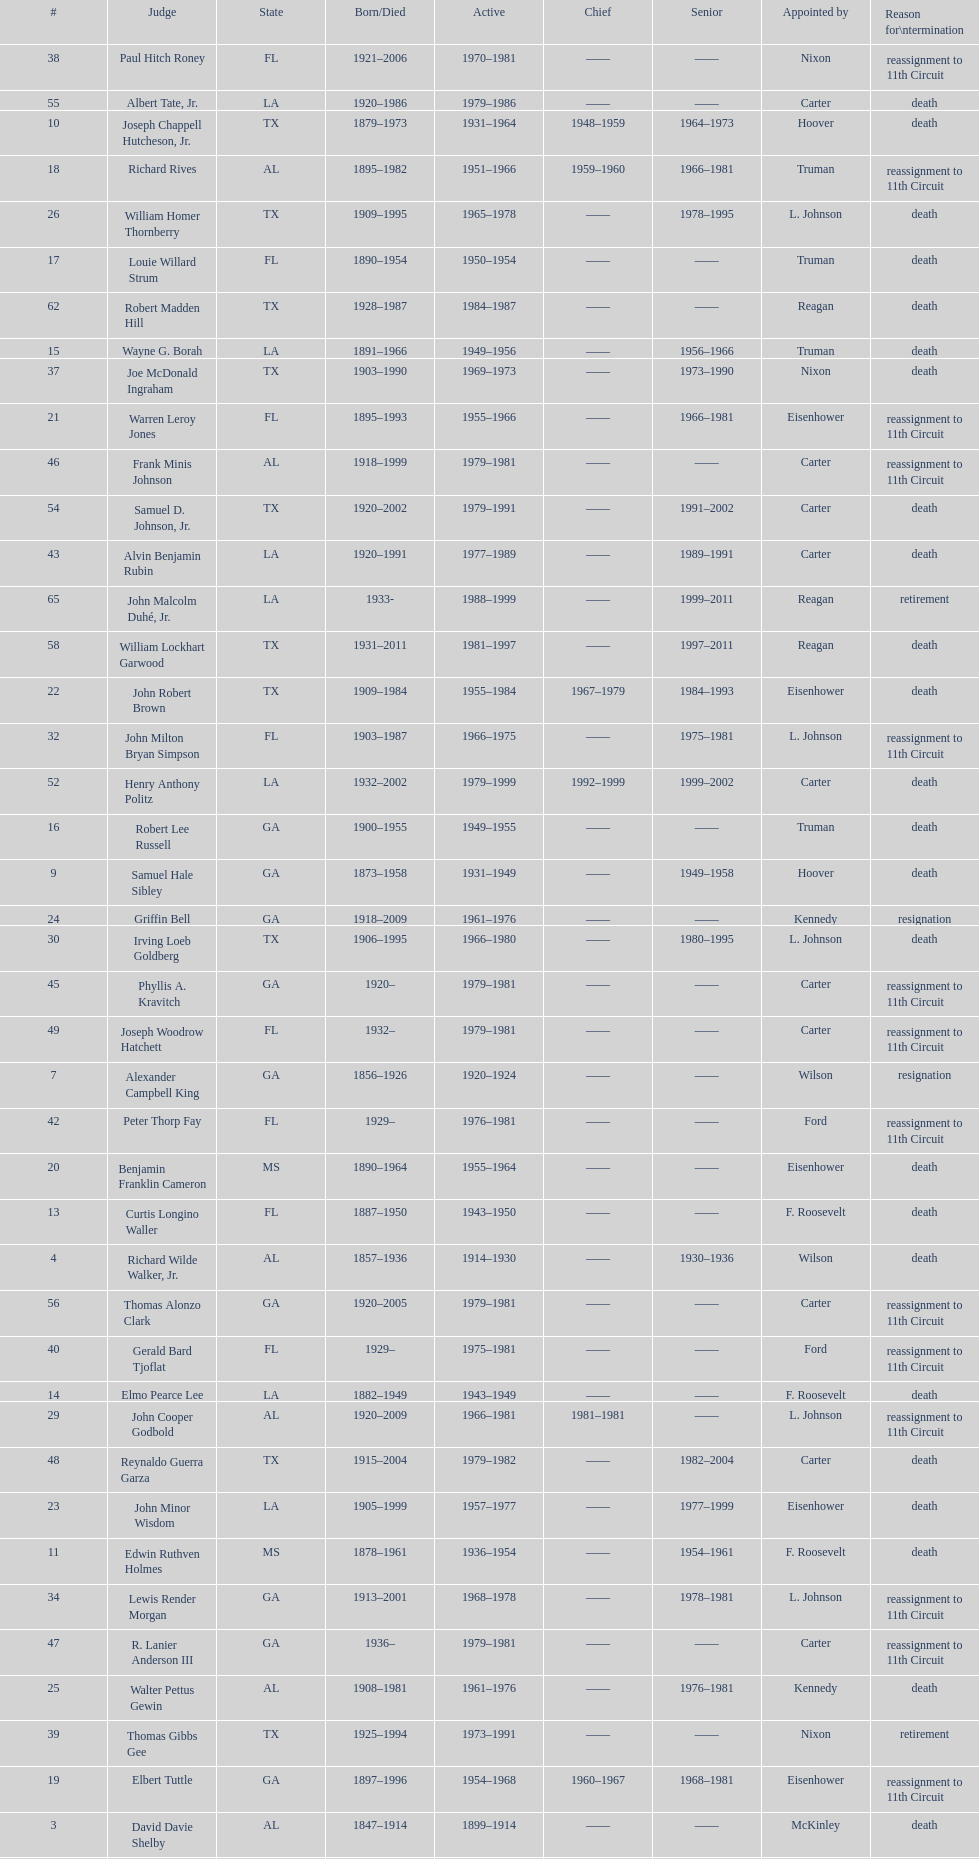Who was the first judge appointed from georgia? Alexander Campbell King. 